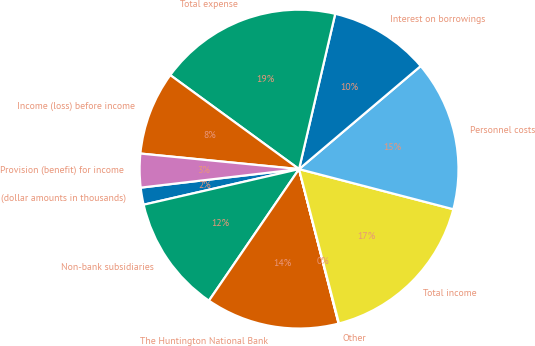<chart> <loc_0><loc_0><loc_500><loc_500><pie_chart><fcel>(dollar amounts in thousands)<fcel>Non-bank subsidiaries<fcel>The Huntington National Bank<fcel>Other<fcel>Total income<fcel>Personnel costs<fcel>Interest on borrowings<fcel>Total expense<fcel>Income (loss) before income<fcel>Provision (benefit) for income<nl><fcel>1.73%<fcel>11.86%<fcel>13.55%<fcel>0.04%<fcel>16.92%<fcel>15.24%<fcel>10.17%<fcel>18.61%<fcel>8.48%<fcel>3.41%<nl></chart> 